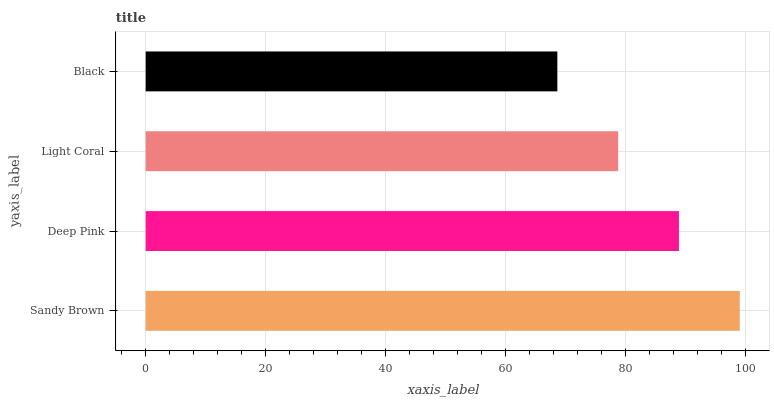Is Black the minimum?
Answer yes or no. Yes. Is Sandy Brown the maximum?
Answer yes or no. Yes. Is Deep Pink the minimum?
Answer yes or no. No. Is Deep Pink the maximum?
Answer yes or no. No. Is Sandy Brown greater than Deep Pink?
Answer yes or no. Yes. Is Deep Pink less than Sandy Brown?
Answer yes or no. Yes. Is Deep Pink greater than Sandy Brown?
Answer yes or no. No. Is Sandy Brown less than Deep Pink?
Answer yes or no. No. Is Deep Pink the high median?
Answer yes or no. Yes. Is Light Coral the low median?
Answer yes or no. Yes. Is Light Coral the high median?
Answer yes or no. No. Is Sandy Brown the low median?
Answer yes or no. No. 